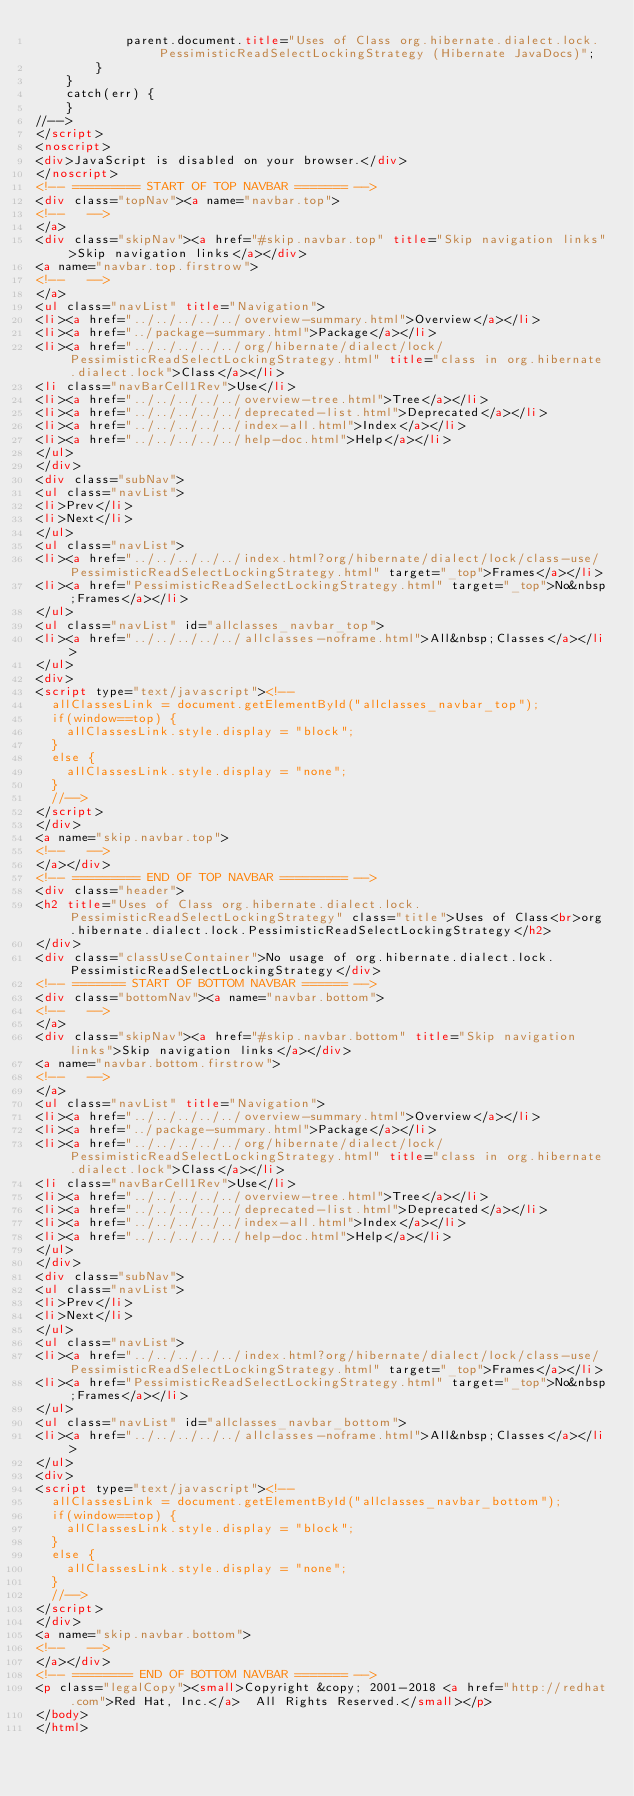<code> <loc_0><loc_0><loc_500><loc_500><_HTML_>            parent.document.title="Uses of Class org.hibernate.dialect.lock.PessimisticReadSelectLockingStrategy (Hibernate JavaDocs)";
        }
    }
    catch(err) {
    }
//-->
</script>
<noscript>
<div>JavaScript is disabled on your browser.</div>
</noscript>
<!-- ========= START OF TOP NAVBAR ======= -->
<div class="topNav"><a name="navbar.top">
<!--   -->
</a>
<div class="skipNav"><a href="#skip.navbar.top" title="Skip navigation links">Skip navigation links</a></div>
<a name="navbar.top.firstrow">
<!--   -->
</a>
<ul class="navList" title="Navigation">
<li><a href="../../../../../overview-summary.html">Overview</a></li>
<li><a href="../package-summary.html">Package</a></li>
<li><a href="../../../../../org/hibernate/dialect/lock/PessimisticReadSelectLockingStrategy.html" title="class in org.hibernate.dialect.lock">Class</a></li>
<li class="navBarCell1Rev">Use</li>
<li><a href="../../../../../overview-tree.html">Tree</a></li>
<li><a href="../../../../../deprecated-list.html">Deprecated</a></li>
<li><a href="../../../../../index-all.html">Index</a></li>
<li><a href="../../../../../help-doc.html">Help</a></li>
</ul>
</div>
<div class="subNav">
<ul class="navList">
<li>Prev</li>
<li>Next</li>
</ul>
<ul class="navList">
<li><a href="../../../../../index.html?org/hibernate/dialect/lock/class-use/PessimisticReadSelectLockingStrategy.html" target="_top">Frames</a></li>
<li><a href="PessimisticReadSelectLockingStrategy.html" target="_top">No&nbsp;Frames</a></li>
</ul>
<ul class="navList" id="allclasses_navbar_top">
<li><a href="../../../../../allclasses-noframe.html">All&nbsp;Classes</a></li>
</ul>
<div>
<script type="text/javascript"><!--
  allClassesLink = document.getElementById("allclasses_navbar_top");
  if(window==top) {
    allClassesLink.style.display = "block";
  }
  else {
    allClassesLink.style.display = "none";
  }
  //-->
</script>
</div>
<a name="skip.navbar.top">
<!--   -->
</a></div>
<!-- ========= END OF TOP NAVBAR ========= -->
<div class="header">
<h2 title="Uses of Class org.hibernate.dialect.lock.PessimisticReadSelectLockingStrategy" class="title">Uses of Class<br>org.hibernate.dialect.lock.PessimisticReadSelectLockingStrategy</h2>
</div>
<div class="classUseContainer">No usage of org.hibernate.dialect.lock.PessimisticReadSelectLockingStrategy</div>
<!-- ======= START OF BOTTOM NAVBAR ====== -->
<div class="bottomNav"><a name="navbar.bottom">
<!--   -->
</a>
<div class="skipNav"><a href="#skip.navbar.bottom" title="Skip navigation links">Skip navigation links</a></div>
<a name="navbar.bottom.firstrow">
<!--   -->
</a>
<ul class="navList" title="Navigation">
<li><a href="../../../../../overview-summary.html">Overview</a></li>
<li><a href="../package-summary.html">Package</a></li>
<li><a href="../../../../../org/hibernate/dialect/lock/PessimisticReadSelectLockingStrategy.html" title="class in org.hibernate.dialect.lock">Class</a></li>
<li class="navBarCell1Rev">Use</li>
<li><a href="../../../../../overview-tree.html">Tree</a></li>
<li><a href="../../../../../deprecated-list.html">Deprecated</a></li>
<li><a href="../../../../../index-all.html">Index</a></li>
<li><a href="../../../../../help-doc.html">Help</a></li>
</ul>
</div>
<div class="subNav">
<ul class="navList">
<li>Prev</li>
<li>Next</li>
</ul>
<ul class="navList">
<li><a href="../../../../../index.html?org/hibernate/dialect/lock/class-use/PessimisticReadSelectLockingStrategy.html" target="_top">Frames</a></li>
<li><a href="PessimisticReadSelectLockingStrategy.html" target="_top">No&nbsp;Frames</a></li>
</ul>
<ul class="navList" id="allclasses_navbar_bottom">
<li><a href="../../../../../allclasses-noframe.html">All&nbsp;Classes</a></li>
</ul>
<div>
<script type="text/javascript"><!--
  allClassesLink = document.getElementById("allclasses_navbar_bottom");
  if(window==top) {
    allClassesLink.style.display = "block";
  }
  else {
    allClassesLink.style.display = "none";
  }
  //-->
</script>
</div>
<a name="skip.navbar.bottom">
<!--   -->
</a></div>
<!-- ======== END OF BOTTOM NAVBAR ======= -->
<p class="legalCopy"><small>Copyright &copy; 2001-2018 <a href="http://redhat.com">Red Hat, Inc.</a>  All Rights Reserved.</small></p>
</body>
</html>
</code> 